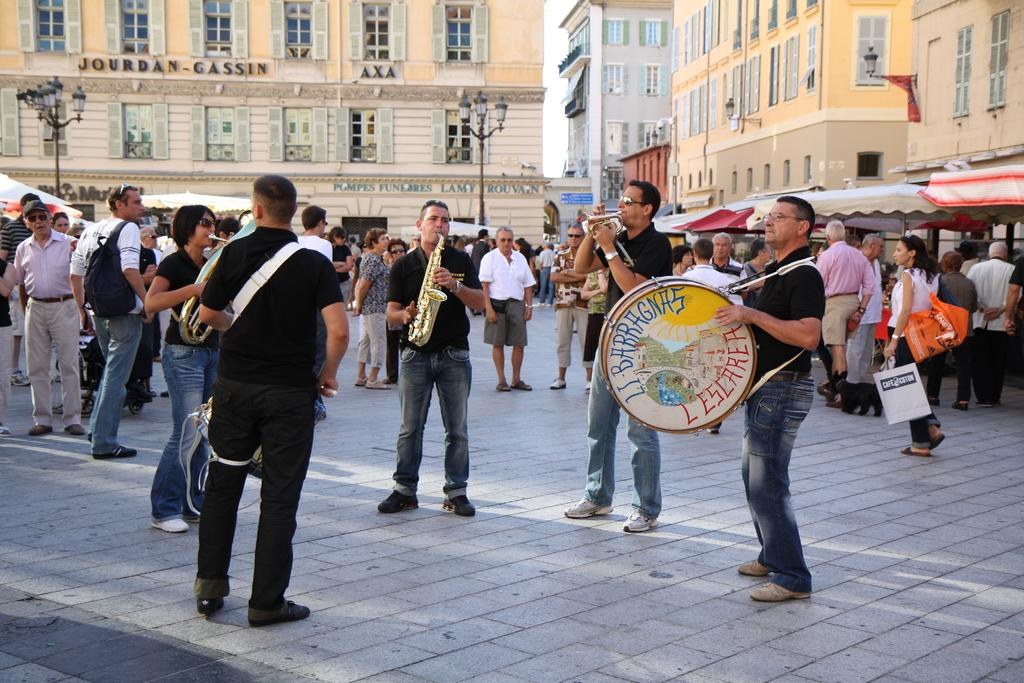Who or what can be seen in the image? There are people in the image. What are the people doing in the image? The people are standing and playing musical instruments. What type of zinc object is being played by the people in the image? There is no zinc object present in the image; the people are playing musical instruments. Can you see any geese in the image? There are no geese present in the image; the main subjects are people playing musical instruments. 